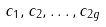Convert formula to latex. <formula><loc_0><loc_0><loc_500><loc_500>c _ { 1 } , c _ { 2 } , \dots , c _ { 2 g }</formula> 